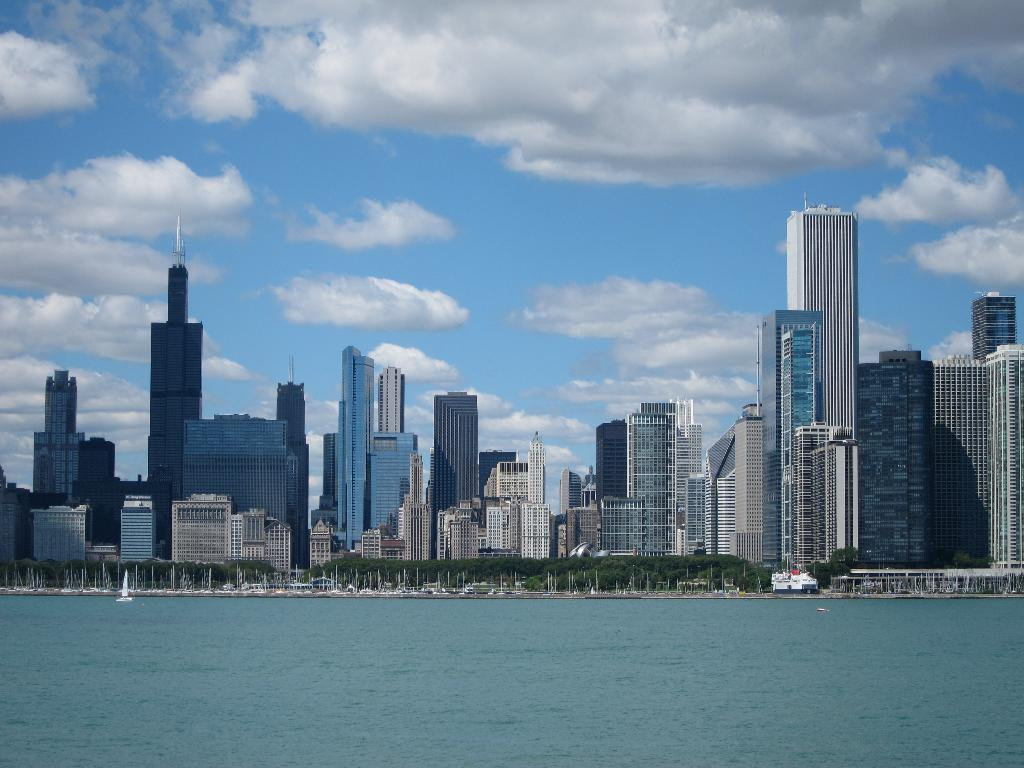What type of structures can be seen in the image? There are many buildings in the image. What other natural elements are present in the image? There are trees in the image. Can you describe any objects related to water in the image? There is a boat visible in the water. What is the condition of the sky in the image? The sky is cloudy in the image. What type of brush is being used to paint the cannon in the image? There is no brush or cannon present in the image. How is the scarf being used by the person in the image? There are no people or scarves present in the image. 